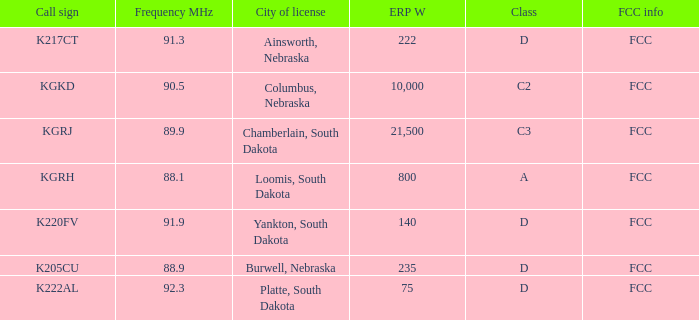I'm looking to parse the entire table for insights. Could you assist me with that? {'header': ['Call sign', 'Frequency MHz', 'City of license', 'ERP W', 'Class', 'FCC info'], 'rows': [['K217CT', '91.3', 'Ainsworth, Nebraska', '222', 'D', 'FCC'], ['KGKD', '90.5', 'Columbus, Nebraska', '10,000', 'C2', 'FCC'], ['KGRJ', '89.9', 'Chamberlain, South Dakota', '21,500', 'C3', 'FCC'], ['KGRH', '88.1', 'Loomis, South Dakota', '800', 'A', 'FCC'], ['K220FV', '91.9', 'Yankton, South Dakota', '140', 'D', 'FCC'], ['K205CU', '88.9', 'Burwell, Nebraska', '235', 'D', 'FCC'], ['K222AL', '92.3', 'Platte, South Dakota', '75', 'D', 'FCC']]} What is the total erp w of class c3, which has a frequency mhz less than 89.9? 0.0. 